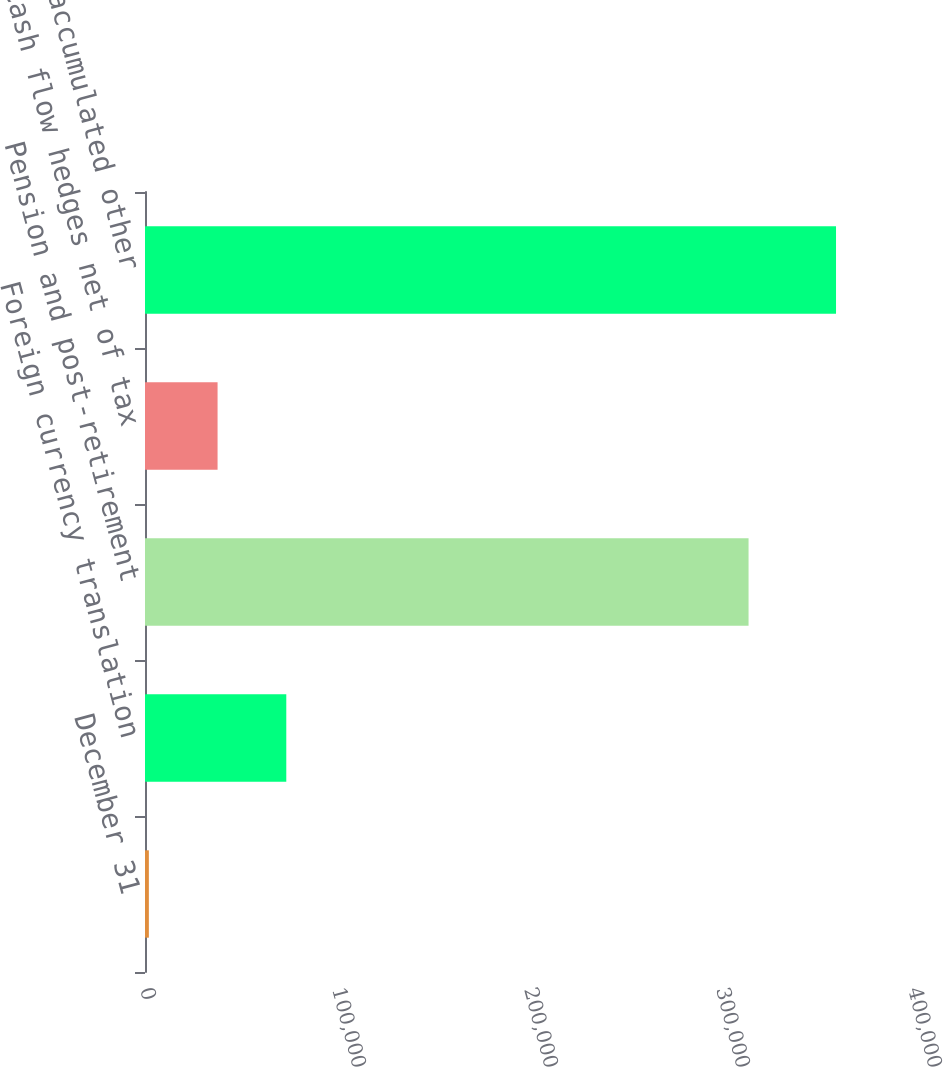Convert chart to OTSL. <chart><loc_0><loc_0><loc_500><loc_500><bar_chart><fcel>December 31<fcel>Foreign currency translation<fcel>Pension and post-retirement<fcel>Cash flow hedges net of tax<fcel>Total accumulated other<nl><fcel>2008<fcel>73588<fcel>314353<fcel>37798<fcel>359908<nl></chart> 